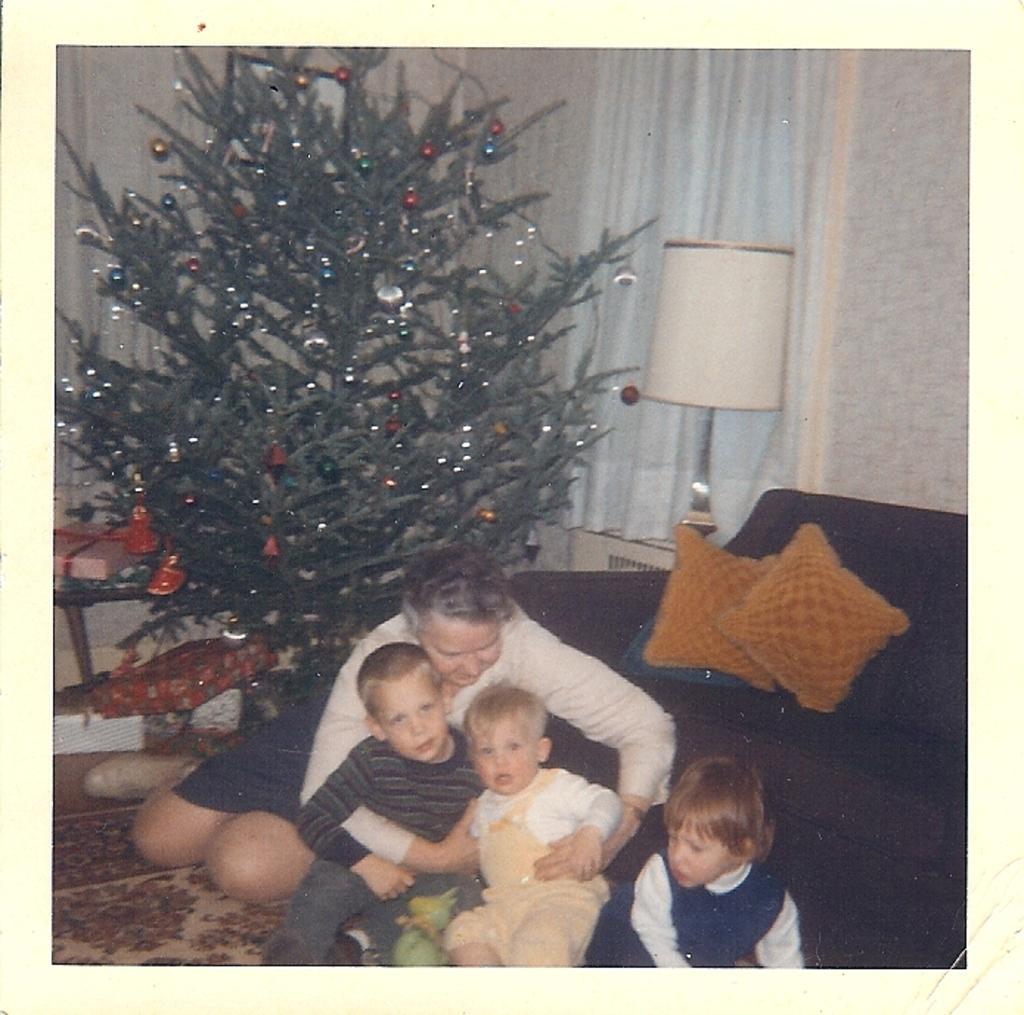How would you summarize this image in a sentence or two? In this image we can see a photocopy in which there is a woman. There are three kids. There is a sofa. There is a Christmas tree. There is a wall, lamp, curtain. At the bottom of the image there is a carpet. 